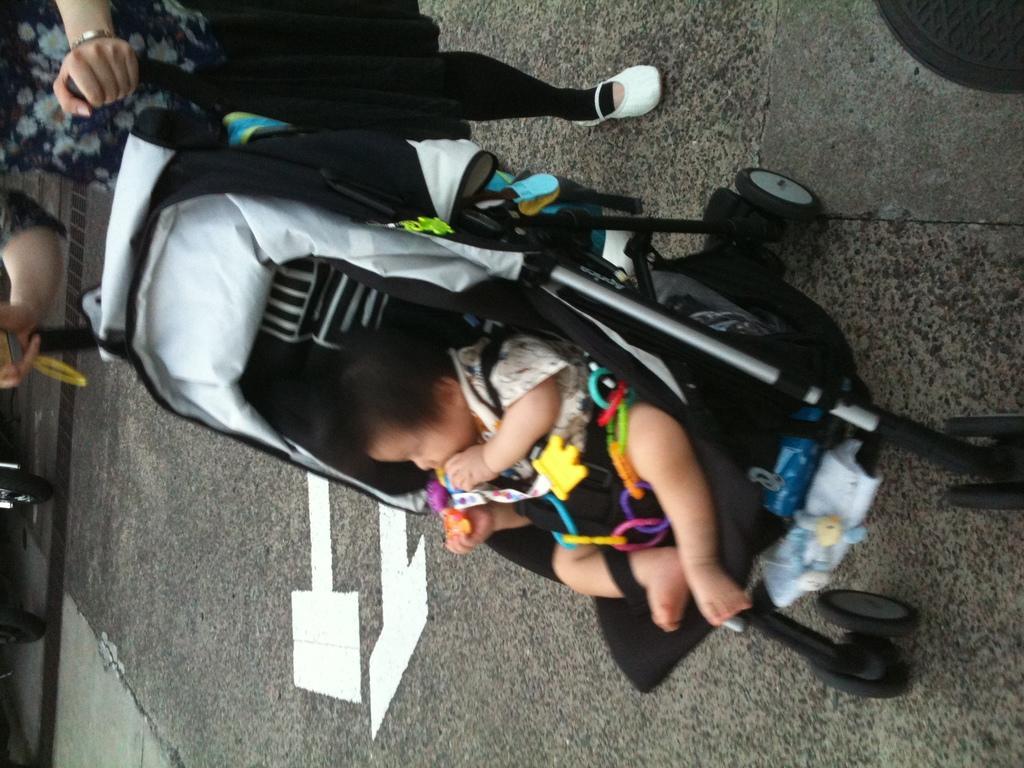Could you give a brief overview of what you see in this image? In the image we can see there is a baby sitting in the buggy. The woman is standing on the road and she is holding the handle of the buggy. 